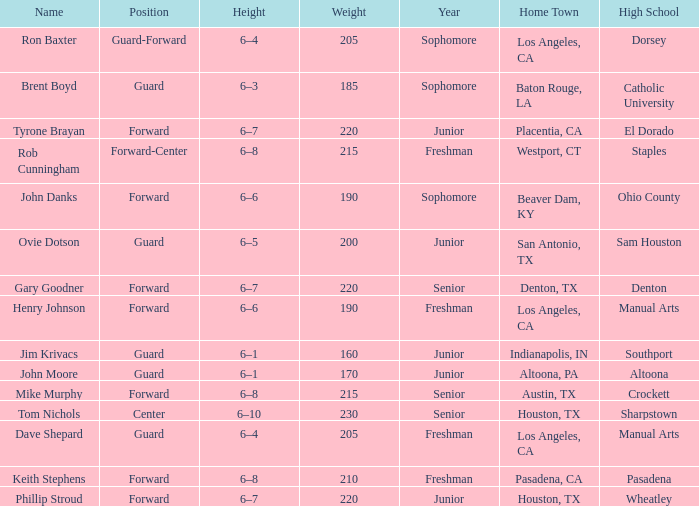What is the identity of a 6'4" tall freshman, originating from los angeles, ca, who has a year in their name? Dave Shepard. 